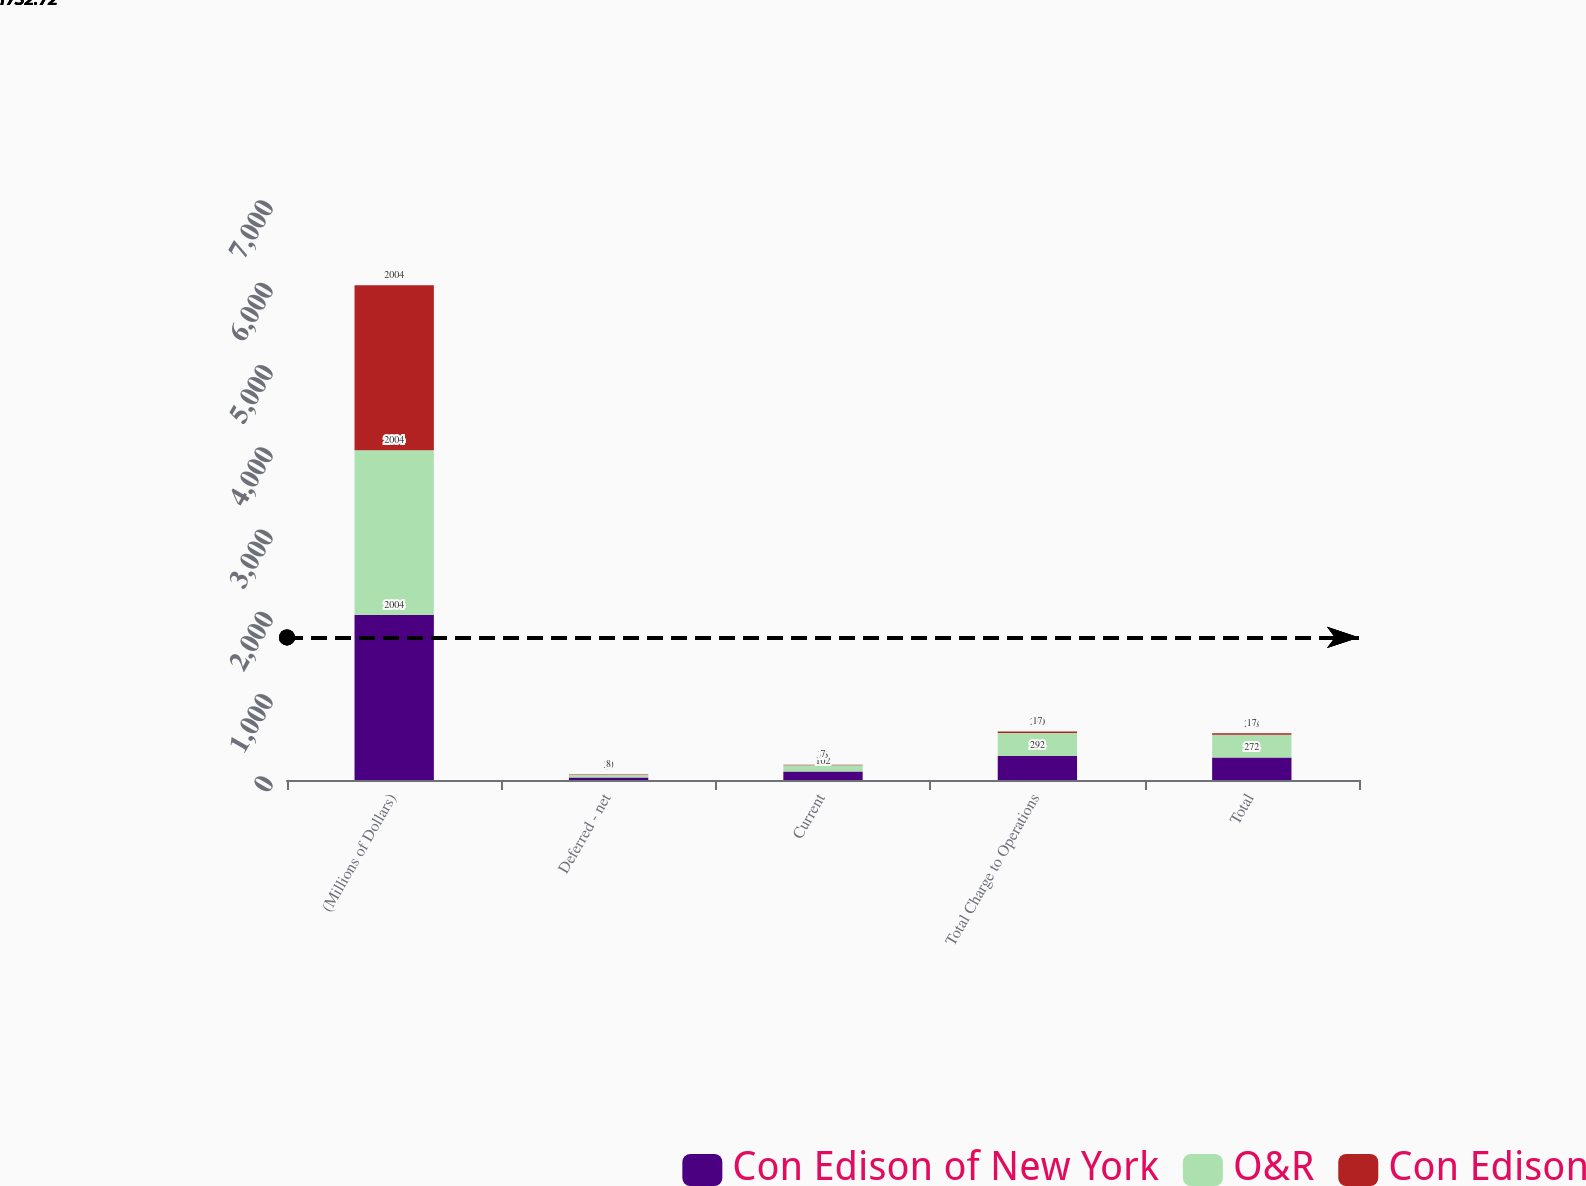Convert chart. <chart><loc_0><loc_0><loc_500><loc_500><stacked_bar_chart><ecel><fcel>(Millions of Dollars)<fcel>Deferred - net<fcel>Current<fcel>Total Charge to Operations<fcel>Total<nl><fcel>Con Edison of New York<fcel>2004<fcel>30<fcel>102<fcel>292<fcel>272<nl><fcel>O&R<fcel>2004<fcel>30<fcel>76<fcel>280<fcel>278<nl><fcel>Con Edison<fcel>2004<fcel>8<fcel>7<fcel>17<fcel>17<nl></chart> 